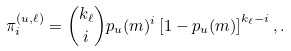<formula> <loc_0><loc_0><loc_500><loc_500>\, \pi ^ { ( u , \ell ) } _ { i } = \binom { k _ { \ell } } { i } p _ { u } ( m ) ^ { i } \left [ 1 - p _ { u } ( m ) \right ] ^ { k _ { \ell } - i } , . \,</formula> 